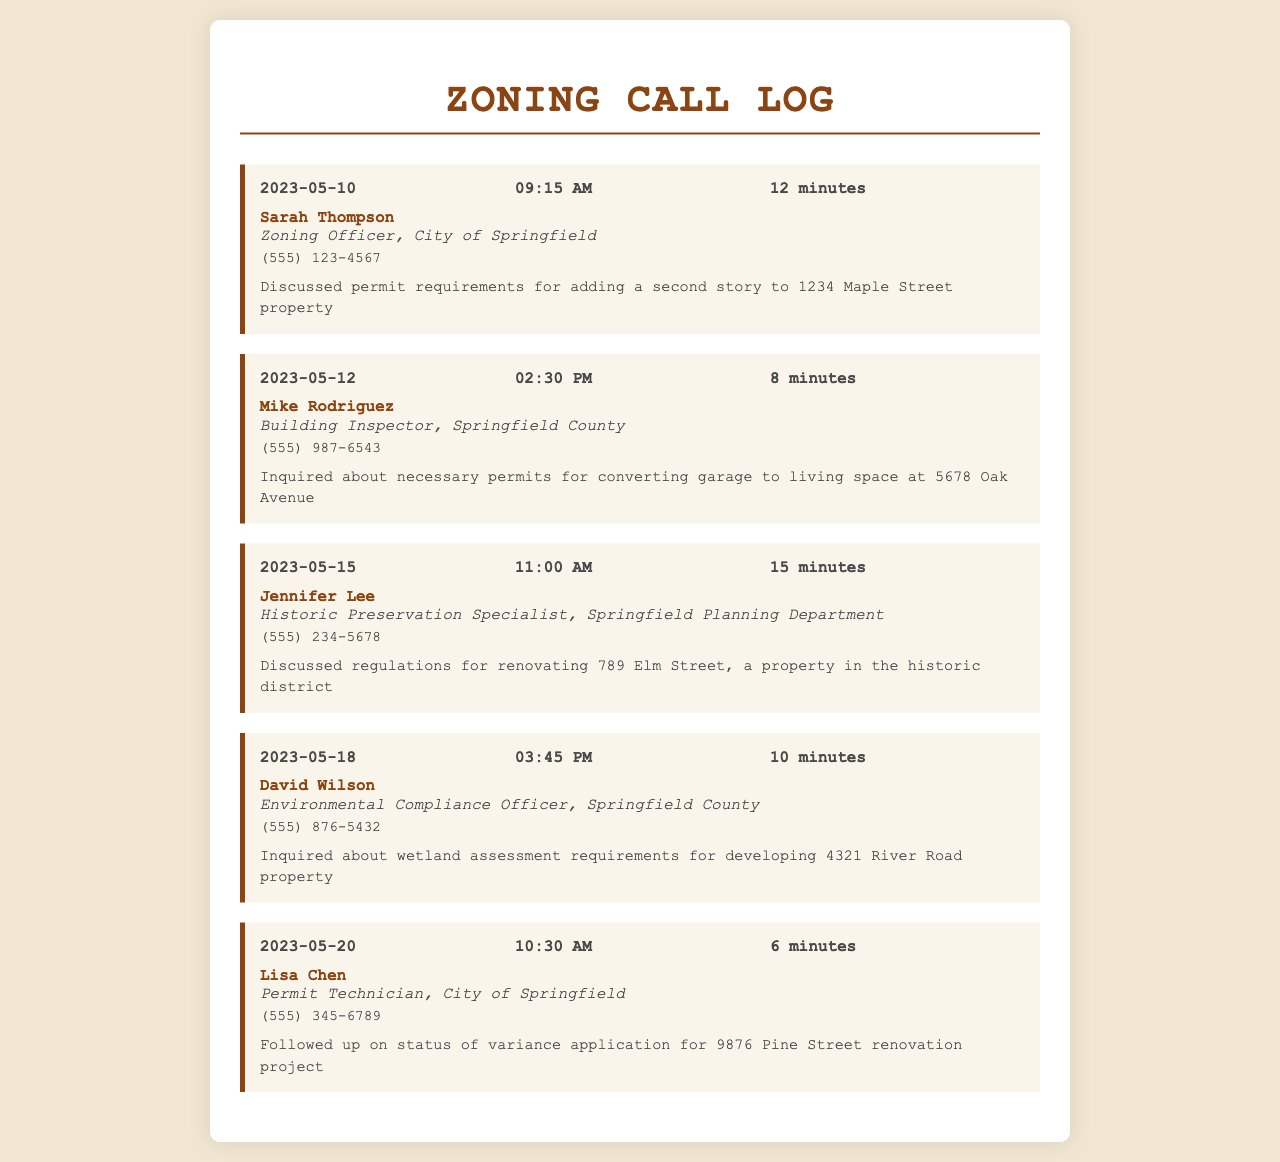What is the date of the first call? The first call in the log is recorded on May 10, 2023.
Answer: May 10, 2023 Who did Sarah Thompson represent? Sarah Thompson is a Zoning Officer for the City of Springfield.
Answer: City of Springfield What was the duration of the call with Mike Rodriguez? The call duration with Mike Rodriguez is noted as 8 minutes.
Answer: 8 minutes What property modification is discussed in the call with Jennifer Lee? The discussion with Jennifer Lee pertains to regulations for renovating a property in the historic district.
Answer: Renovating 789 Elm Street How many minutes was the call with Lisa Chen? The call with Lisa Chen lasted for 6 minutes.
Answer: 6 minutes Which zoning official was contacted regarding wetland assessment? The official contacted for wetland assessment requirements is David Wilson.
Answer: David Wilson On what date was the follow-up on the variance application made? The follow-up was made on May 20, 2023.
Answer: May 20, 2023 What is the title of Jennifer Lee? Jennifer Lee holds the title of Historic Preservation Specialist.
Answer: Historic Preservation Specialist How many calls were made to local zoning officials in total? There are a total of five calls recorded in the log.
Answer: Five 